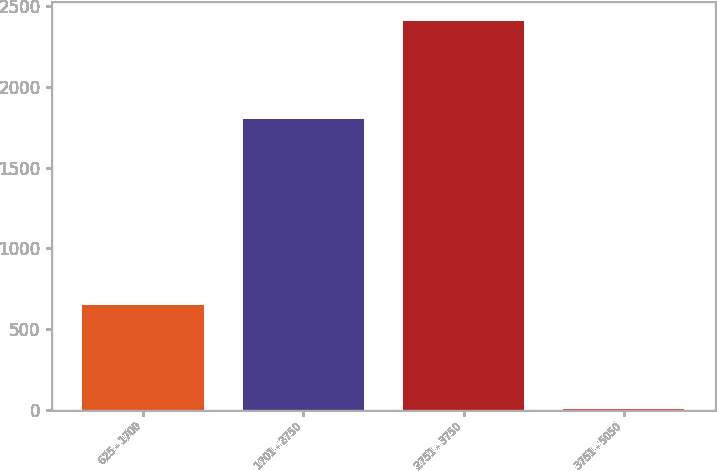Convert chart to OTSL. <chart><loc_0><loc_0><loc_500><loc_500><bar_chart><fcel>625 - 1700<fcel>1701 - 2750<fcel>2751 - 3750<fcel>3751 - 5050<nl><fcel>651<fcel>1802<fcel>2409<fcel>4<nl></chart> 